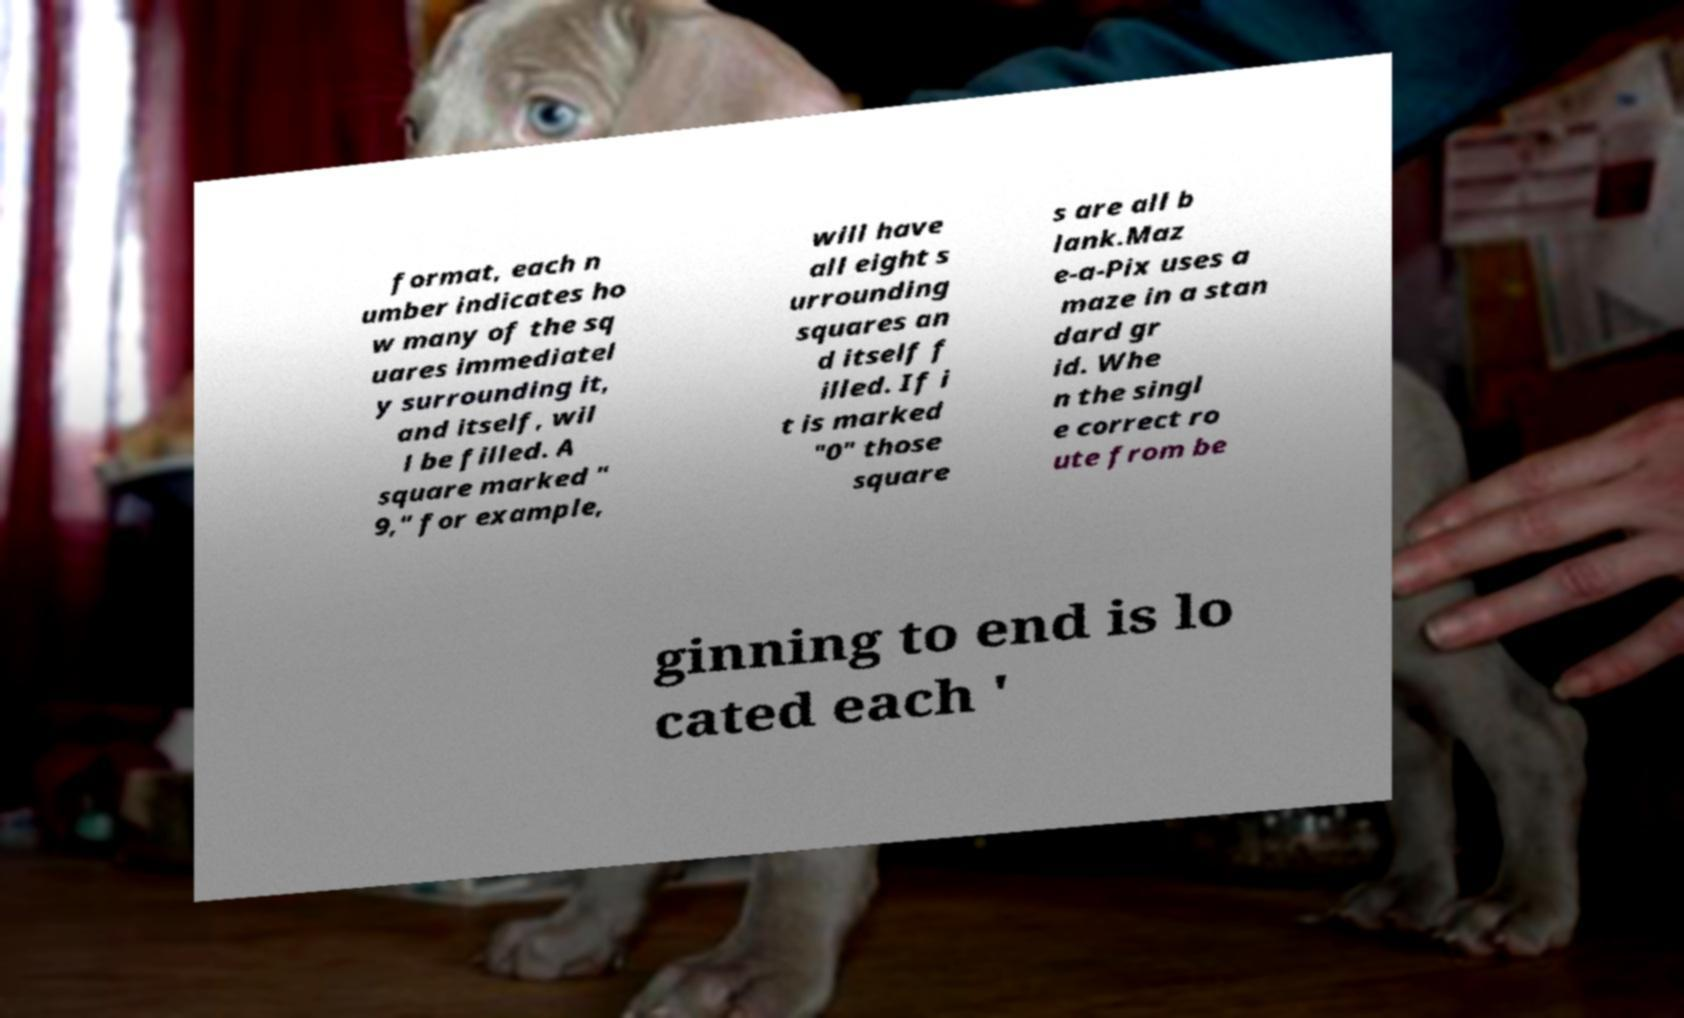I need the written content from this picture converted into text. Can you do that? format, each n umber indicates ho w many of the sq uares immediatel y surrounding it, and itself, wil l be filled. A square marked " 9," for example, will have all eight s urrounding squares an d itself f illed. If i t is marked "0" those square s are all b lank.Maz e-a-Pix uses a maze in a stan dard gr id. Whe n the singl e correct ro ute from be ginning to end is lo cated each ' 